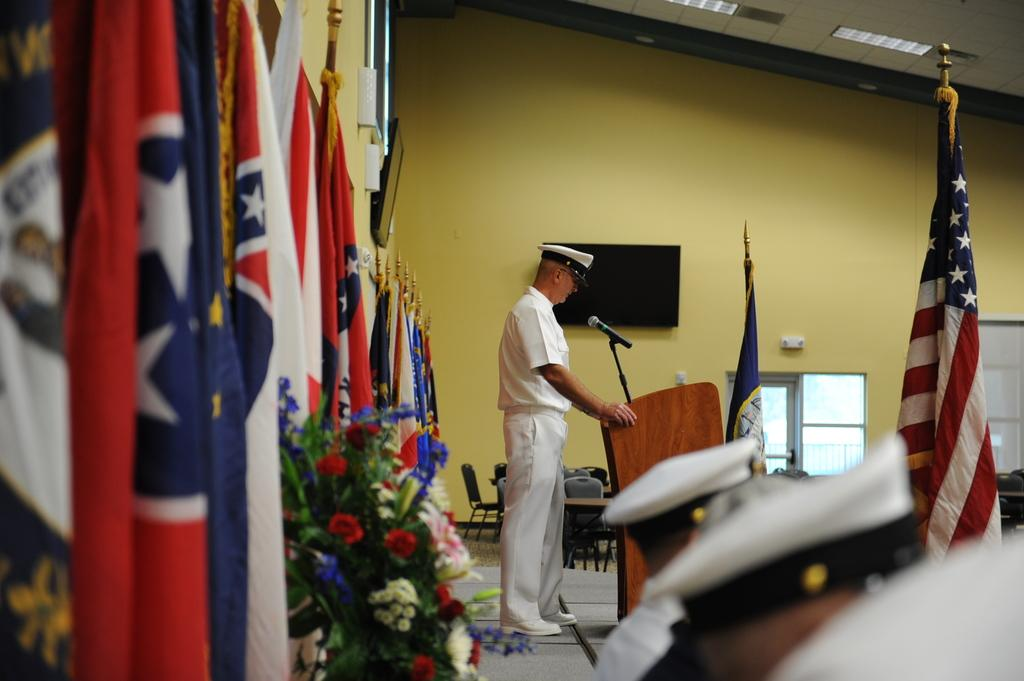What is the man in the image doing? The man is standing and speaking in the image. What are the other people in the image doing? The other people are sitting in the image. What can be seen on the dais in the image? There are flags on the dais in the image. What is visible in the background of the image? There is a wall in the backdrop of the image. What type of vegetable is being used as a microphone in the image? There is no vegetable being used as a microphone in the image; the man is using a conventional microphone to speak. 